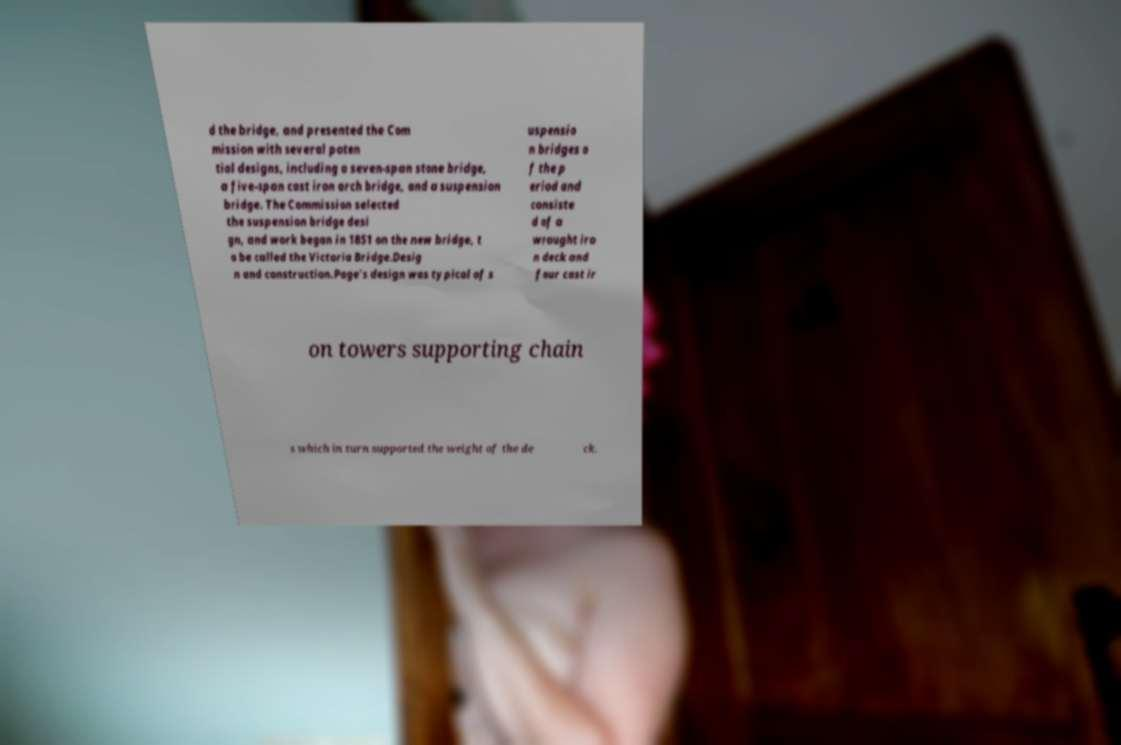Could you extract and type out the text from this image? d the bridge, and presented the Com mission with several poten tial designs, including a seven-span stone bridge, a five-span cast iron arch bridge, and a suspension bridge. The Commission selected the suspension bridge desi gn, and work began in 1851 on the new bridge, t o be called the Victoria Bridge.Desig n and construction.Page's design was typical of s uspensio n bridges o f the p eriod and consiste d of a wrought iro n deck and four cast ir on towers supporting chain s which in turn supported the weight of the de ck. 